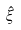Convert formula to latex. <formula><loc_0><loc_0><loc_500><loc_500>\hat { \xi }</formula> 